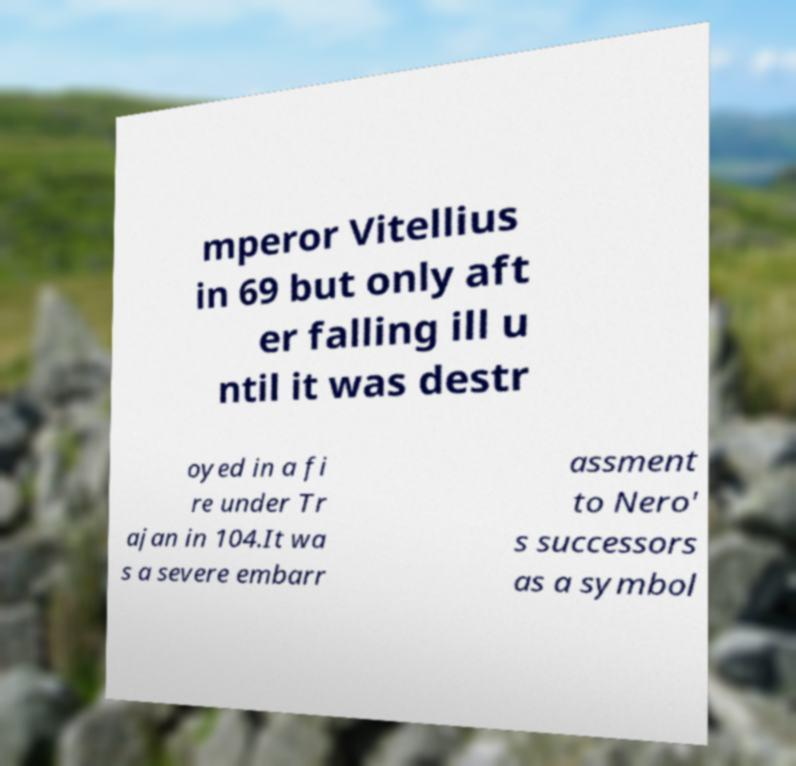Could you assist in decoding the text presented in this image and type it out clearly? mperor Vitellius in 69 but only aft er falling ill u ntil it was destr oyed in a fi re under Tr ajan in 104.It wa s a severe embarr assment to Nero' s successors as a symbol 